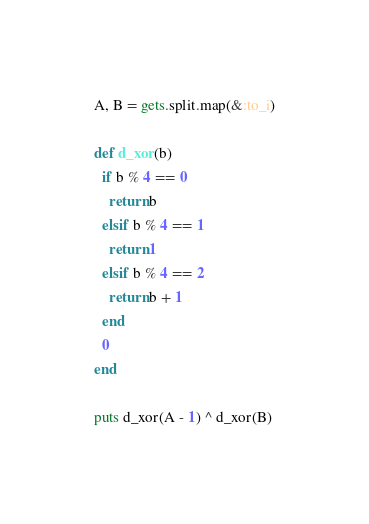Convert code to text. <code><loc_0><loc_0><loc_500><loc_500><_Ruby_>A, B = gets.split.map(&:to_i)

def d_xor(b)
  if b % 4 == 0
    return b
  elsif b % 4 == 1
    return 1
  elsif b % 4 == 2
    return b + 1
  end
  0
end

puts d_xor(A - 1) ^ d_xor(B)</code> 